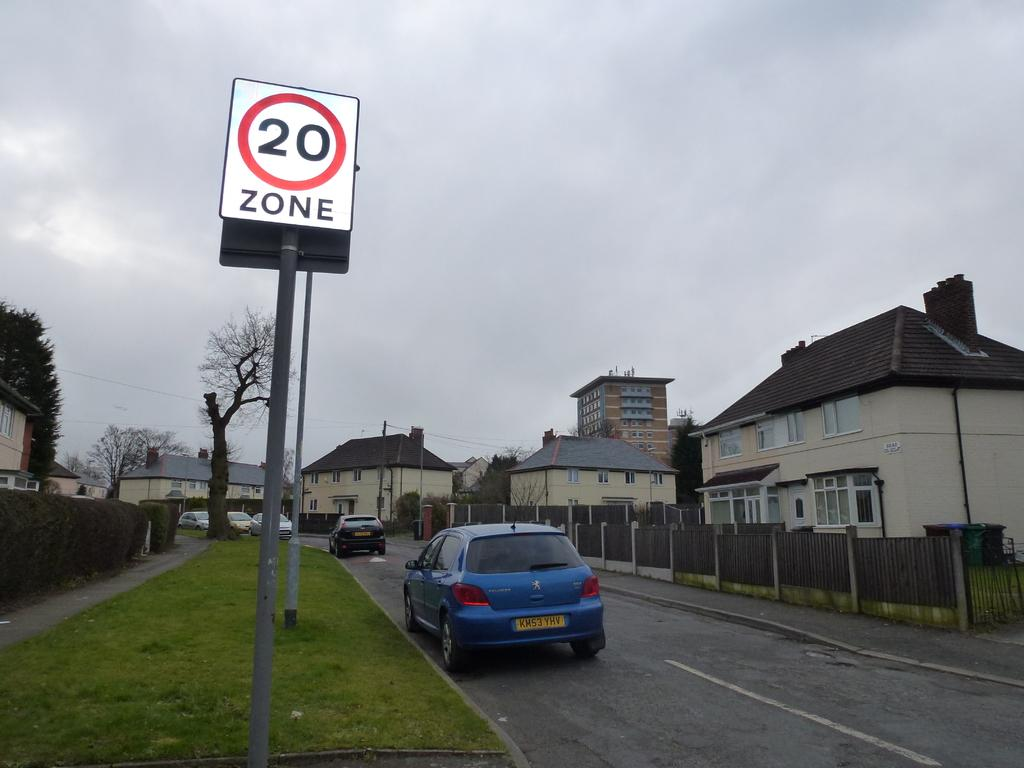Provide a one-sentence caption for the provided image. A village with a speed limit sign of 20. 